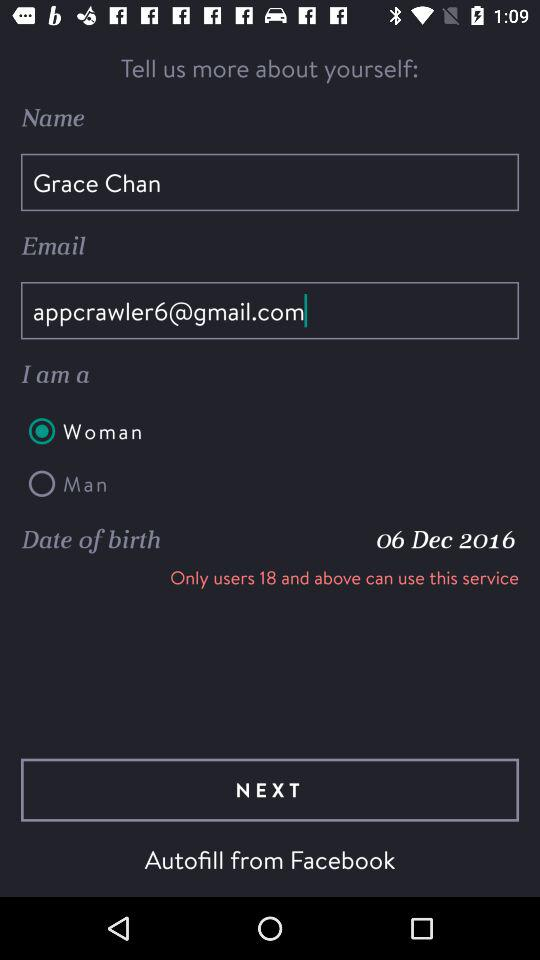What is the email address? The email address is appcrawler6@gmail.com. 